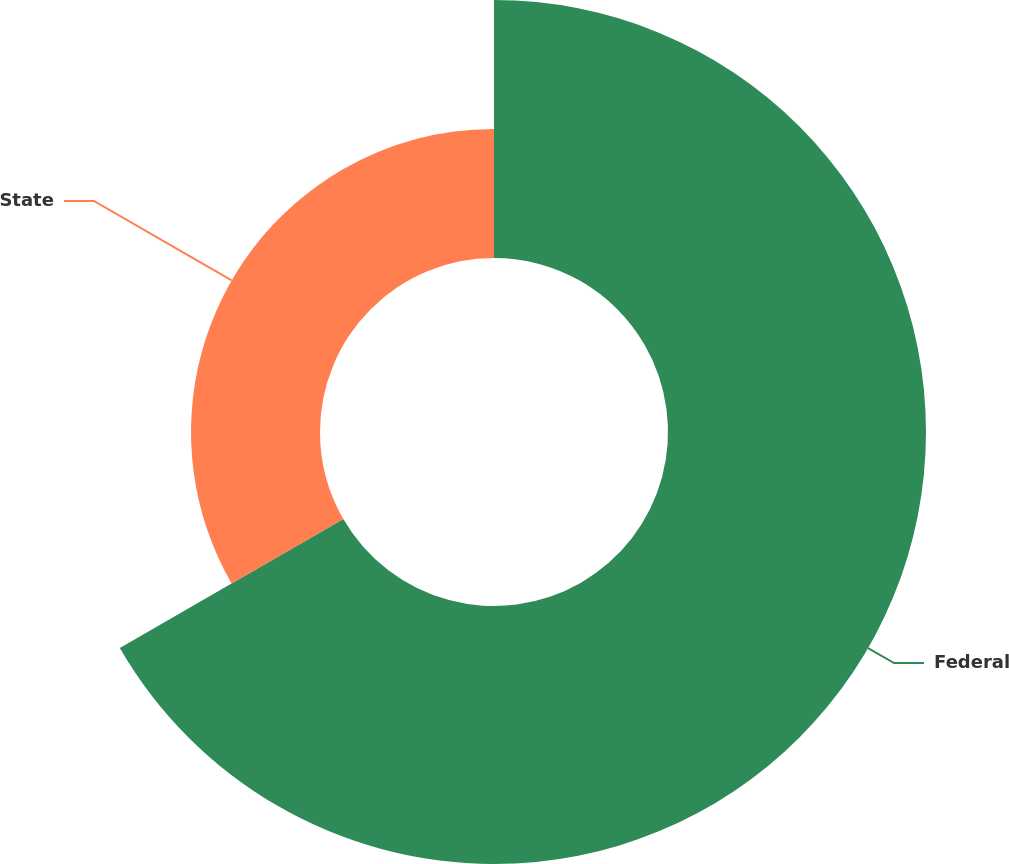Convert chart to OTSL. <chart><loc_0><loc_0><loc_500><loc_500><pie_chart><fcel>Federal<fcel>State<nl><fcel>66.67%<fcel>33.33%<nl></chart> 